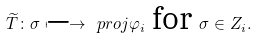<formula> <loc_0><loc_0><loc_500><loc_500>\widetilde { T } \colon \sigma \longmapsto \ p r o j { \varphi _ { i } } \text { for } \sigma \in Z _ { i } .</formula> 